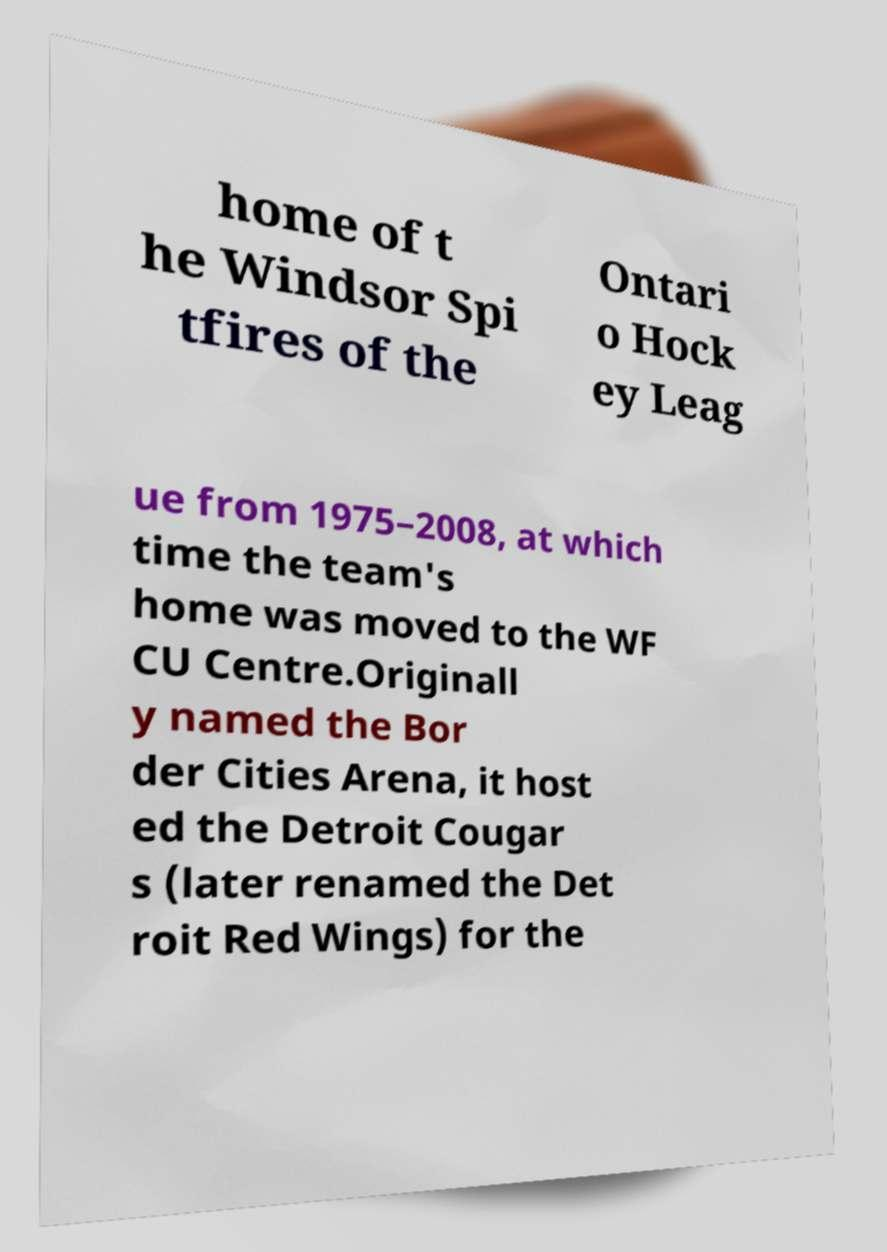There's text embedded in this image that I need extracted. Can you transcribe it verbatim? home of t he Windsor Spi tfires of the Ontari o Hock ey Leag ue from 1975–2008, at which time the team's home was moved to the WF CU Centre.Originall y named the Bor der Cities Arena, it host ed the Detroit Cougar s (later renamed the Det roit Red Wings) for the 